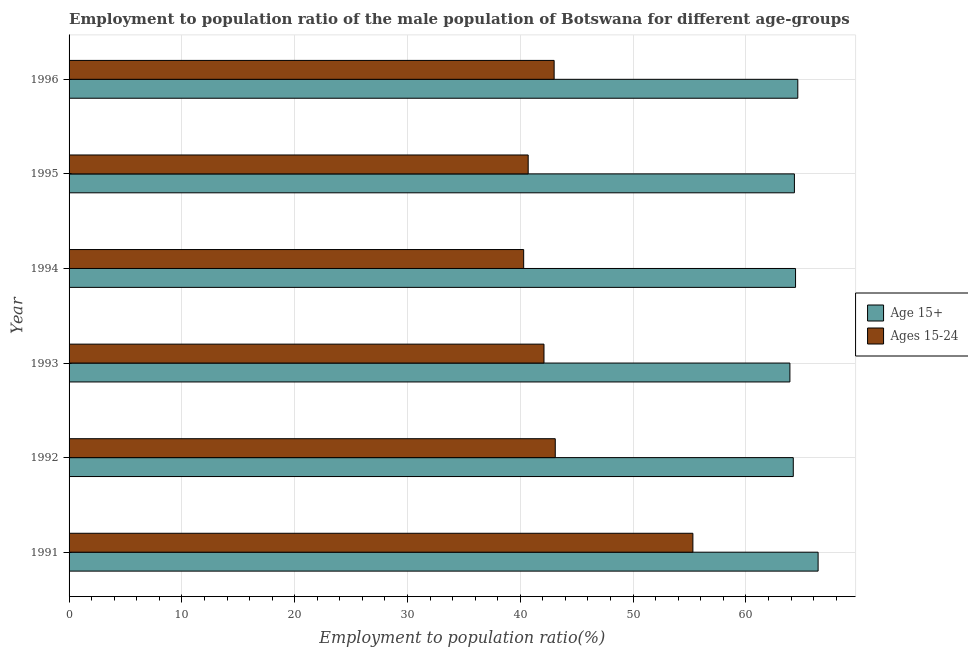How many bars are there on the 3rd tick from the bottom?
Provide a succinct answer. 2. What is the label of the 5th group of bars from the top?
Provide a short and direct response. 1992. In how many cases, is the number of bars for a given year not equal to the number of legend labels?
Offer a very short reply. 0. What is the employment to population ratio(age 15+) in 1996?
Offer a very short reply. 64.6. Across all years, what is the maximum employment to population ratio(age 15-24)?
Keep it short and to the point. 55.3. Across all years, what is the minimum employment to population ratio(age 15-24)?
Keep it short and to the point. 40.3. What is the total employment to population ratio(age 15+) in the graph?
Give a very brief answer. 387.8. What is the difference between the employment to population ratio(age 15-24) in 1991 and the employment to population ratio(age 15+) in 1993?
Ensure brevity in your answer.  -8.6. What is the average employment to population ratio(age 15-24) per year?
Keep it short and to the point. 44.08. In the year 1996, what is the difference between the employment to population ratio(age 15-24) and employment to population ratio(age 15+)?
Your response must be concise. -21.6. In how many years, is the employment to population ratio(age 15-24) greater than 44 %?
Your answer should be very brief. 1. What is the ratio of the employment to population ratio(age 15+) in 1995 to that in 1996?
Offer a very short reply. 0.99. Is the employment to population ratio(age 15+) in 1991 less than that in 1993?
Provide a short and direct response. No. Is the difference between the employment to population ratio(age 15+) in 1994 and 1996 greater than the difference between the employment to population ratio(age 15-24) in 1994 and 1996?
Keep it short and to the point. Yes. What is the difference between the highest and the second highest employment to population ratio(age 15-24)?
Your answer should be compact. 12.2. What is the difference between the highest and the lowest employment to population ratio(age 15+)?
Provide a short and direct response. 2.5. In how many years, is the employment to population ratio(age 15+) greater than the average employment to population ratio(age 15+) taken over all years?
Offer a terse response. 1. What does the 1st bar from the top in 1993 represents?
Offer a terse response. Ages 15-24. What does the 1st bar from the bottom in 1994 represents?
Ensure brevity in your answer.  Age 15+. How many bars are there?
Your answer should be very brief. 12. How many years are there in the graph?
Your answer should be very brief. 6. Does the graph contain any zero values?
Provide a short and direct response. No. How many legend labels are there?
Your response must be concise. 2. How are the legend labels stacked?
Make the answer very short. Vertical. What is the title of the graph?
Your response must be concise. Employment to population ratio of the male population of Botswana for different age-groups. Does "Forest" appear as one of the legend labels in the graph?
Keep it short and to the point. No. What is the label or title of the Y-axis?
Your answer should be very brief. Year. What is the Employment to population ratio(%) in Age 15+ in 1991?
Keep it short and to the point. 66.4. What is the Employment to population ratio(%) of Ages 15-24 in 1991?
Give a very brief answer. 55.3. What is the Employment to population ratio(%) in Age 15+ in 1992?
Keep it short and to the point. 64.2. What is the Employment to population ratio(%) in Ages 15-24 in 1992?
Your response must be concise. 43.1. What is the Employment to population ratio(%) in Age 15+ in 1993?
Make the answer very short. 63.9. What is the Employment to population ratio(%) in Ages 15-24 in 1993?
Keep it short and to the point. 42.1. What is the Employment to population ratio(%) of Age 15+ in 1994?
Your response must be concise. 64.4. What is the Employment to population ratio(%) in Ages 15-24 in 1994?
Provide a succinct answer. 40.3. What is the Employment to population ratio(%) in Age 15+ in 1995?
Keep it short and to the point. 64.3. What is the Employment to population ratio(%) of Ages 15-24 in 1995?
Keep it short and to the point. 40.7. What is the Employment to population ratio(%) in Age 15+ in 1996?
Offer a very short reply. 64.6. Across all years, what is the maximum Employment to population ratio(%) in Age 15+?
Your response must be concise. 66.4. Across all years, what is the maximum Employment to population ratio(%) of Ages 15-24?
Provide a short and direct response. 55.3. Across all years, what is the minimum Employment to population ratio(%) in Age 15+?
Keep it short and to the point. 63.9. Across all years, what is the minimum Employment to population ratio(%) in Ages 15-24?
Your answer should be very brief. 40.3. What is the total Employment to population ratio(%) in Age 15+ in the graph?
Keep it short and to the point. 387.8. What is the total Employment to population ratio(%) of Ages 15-24 in the graph?
Your answer should be compact. 264.5. What is the difference between the Employment to population ratio(%) in Age 15+ in 1991 and that in 1992?
Give a very brief answer. 2.2. What is the difference between the Employment to population ratio(%) in Ages 15-24 in 1991 and that in 1992?
Your response must be concise. 12.2. What is the difference between the Employment to population ratio(%) of Ages 15-24 in 1991 and that in 1993?
Provide a short and direct response. 13.2. What is the difference between the Employment to population ratio(%) in Ages 15-24 in 1991 and that in 1994?
Your answer should be very brief. 15. What is the difference between the Employment to population ratio(%) of Age 15+ in 1991 and that in 1996?
Provide a short and direct response. 1.8. What is the difference between the Employment to population ratio(%) in Ages 15-24 in 1991 and that in 1996?
Offer a very short reply. 12.3. What is the difference between the Employment to population ratio(%) of Age 15+ in 1992 and that in 1993?
Offer a terse response. 0.3. What is the difference between the Employment to population ratio(%) of Ages 15-24 in 1992 and that in 1993?
Offer a terse response. 1. What is the difference between the Employment to population ratio(%) in Age 15+ in 1992 and that in 1994?
Keep it short and to the point. -0.2. What is the difference between the Employment to population ratio(%) in Ages 15-24 in 1992 and that in 1994?
Provide a short and direct response. 2.8. What is the difference between the Employment to population ratio(%) of Ages 15-24 in 1992 and that in 1995?
Offer a very short reply. 2.4. What is the difference between the Employment to population ratio(%) of Ages 15-24 in 1992 and that in 1996?
Offer a very short reply. 0.1. What is the difference between the Employment to population ratio(%) in Age 15+ in 1993 and that in 1994?
Make the answer very short. -0.5. What is the difference between the Employment to population ratio(%) in Ages 15-24 in 1993 and that in 1994?
Provide a succinct answer. 1.8. What is the difference between the Employment to population ratio(%) of Ages 15-24 in 1993 and that in 1995?
Provide a short and direct response. 1.4. What is the difference between the Employment to population ratio(%) of Age 15+ in 1993 and that in 1996?
Ensure brevity in your answer.  -0.7. What is the difference between the Employment to population ratio(%) of Ages 15-24 in 1993 and that in 1996?
Your response must be concise. -0.9. What is the difference between the Employment to population ratio(%) in Ages 15-24 in 1994 and that in 1995?
Give a very brief answer. -0.4. What is the difference between the Employment to population ratio(%) in Age 15+ in 1995 and that in 1996?
Offer a very short reply. -0.3. What is the difference between the Employment to population ratio(%) of Age 15+ in 1991 and the Employment to population ratio(%) of Ages 15-24 in 1992?
Offer a terse response. 23.3. What is the difference between the Employment to population ratio(%) in Age 15+ in 1991 and the Employment to population ratio(%) in Ages 15-24 in 1993?
Provide a short and direct response. 24.3. What is the difference between the Employment to population ratio(%) of Age 15+ in 1991 and the Employment to population ratio(%) of Ages 15-24 in 1994?
Your answer should be very brief. 26.1. What is the difference between the Employment to population ratio(%) in Age 15+ in 1991 and the Employment to population ratio(%) in Ages 15-24 in 1995?
Provide a succinct answer. 25.7. What is the difference between the Employment to population ratio(%) of Age 15+ in 1991 and the Employment to population ratio(%) of Ages 15-24 in 1996?
Make the answer very short. 23.4. What is the difference between the Employment to population ratio(%) of Age 15+ in 1992 and the Employment to population ratio(%) of Ages 15-24 in 1993?
Ensure brevity in your answer.  22.1. What is the difference between the Employment to population ratio(%) of Age 15+ in 1992 and the Employment to population ratio(%) of Ages 15-24 in 1994?
Provide a short and direct response. 23.9. What is the difference between the Employment to population ratio(%) in Age 15+ in 1992 and the Employment to population ratio(%) in Ages 15-24 in 1996?
Your answer should be compact. 21.2. What is the difference between the Employment to population ratio(%) of Age 15+ in 1993 and the Employment to population ratio(%) of Ages 15-24 in 1994?
Your answer should be very brief. 23.6. What is the difference between the Employment to population ratio(%) of Age 15+ in 1993 and the Employment to population ratio(%) of Ages 15-24 in 1995?
Provide a short and direct response. 23.2. What is the difference between the Employment to population ratio(%) of Age 15+ in 1993 and the Employment to population ratio(%) of Ages 15-24 in 1996?
Ensure brevity in your answer.  20.9. What is the difference between the Employment to population ratio(%) in Age 15+ in 1994 and the Employment to population ratio(%) in Ages 15-24 in 1995?
Make the answer very short. 23.7. What is the difference between the Employment to population ratio(%) in Age 15+ in 1994 and the Employment to population ratio(%) in Ages 15-24 in 1996?
Provide a succinct answer. 21.4. What is the difference between the Employment to population ratio(%) of Age 15+ in 1995 and the Employment to population ratio(%) of Ages 15-24 in 1996?
Provide a short and direct response. 21.3. What is the average Employment to population ratio(%) in Age 15+ per year?
Keep it short and to the point. 64.63. What is the average Employment to population ratio(%) in Ages 15-24 per year?
Give a very brief answer. 44.08. In the year 1992, what is the difference between the Employment to population ratio(%) of Age 15+ and Employment to population ratio(%) of Ages 15-24?
Provide a succinct answer. 21.1. In the year 1993, what is the difference between the Employment to population ratio(%) of Age 15+ and Employment to population ratio(%) of Ages 15-24?
Give a very brief answer. 21.8. In the year 1994, what is the difference between the Employment to population ratio(%) in Age 15+ and Employment to population ratio(%) in Ages 15-24?
Provide a succinct answer. 24.1. In the year 1995, what is the difference between the Employment to population ratio(%) of Age 15+ and Employment to population ratio(%) of Ages 15-24?
Your answer should be compact. 23.6. In the year 1996, what is the difference between the Employment to population ratio(%) of Age 15+ and Employment to population ratio(%) of Ages 15-24?
Provide a succinct answer. 21.6. What is the ratio of the Employment to population ratio(%) of Age 15+ in 1991 to that in 1992?
Your answer should be compact. 1.03. What is the ratio of the Employment to population ratio(%) in Ages 15-24 in 1991 to that in 1992?
Keep it short and to the point. 1.28. What is the ratio of the Employment to population ratio(%) of Age 15+ in 1991 to that in 1993?
Provide a succinct answer. 1.04. What is the ratio of the Employment to population ratio(%) of Ages 15-24 in 1991 to that in 1993?
Give a very brief answer. 1.31. What is the ratio of the Employment to population ratio(%) of Age 15+ in 1991 to that in 1994?
Your answer should be compact. 1.03. What is the ratio of the Employment to population ratio(%) of Ages 15-24 in 1991 to that in 1994?
Keep it short and to the point. 1.37. What is the ratio of the Employment to population ratio(%) of Age 15+ in 1991 to that in 1995?
Give a very brief answer. 1.03. What is the ratio of the Employment to population ratio(%) in Ages 15-24 in 1991 to that in 1995?
Your response must be concise. 1.36. What is the ratio of the Employment to population ratio(%) in Age 15+ in 1991 to that in 1996?
Keep it short and to the point. 1.03. What is the ratio of the Employment to population ratio(%) in Ages 15-24 in 1991 to that in 1996?
Offer a terse response. 1.29. What is the ratio of the Employment to population ratio(%) of Ages 15-24 in 1992 to that in 1993?
Your answer should be very brief. 1.02. What is the ratio of the Employment to population ratio(%) in Ages 15-24 in 1992 to that in 1994?
Provide a succinct answer. 1.07. What is the ratio of the Employment to population ratio(%) in Ages 15-24 in 1992 to that in 1995?
Offer a very short reply. 1.06. What is the ratio of the Employment to population ratio(%) in Age 15+ in 1992 to that in 1996?
Your response must be concise. 0.99. What is the ratio of the Employment to population ratio(%) in Age 15+ in 1993 to that in 1994?
Your answer should be very brief. 0.99. What is the ratio of the Employment to population ratio(%) in Ages 15-24 in 1993 to that in 1994?
Keep it short and to the point. 1.04. What is the ratio of the Employment to population ratio(%) in Ages 15-24 in 1993 to that in 1995?
Your answer should be very brief. 1.03. What is the ratio of the Employment to population ratio(%) of Age 15+ in 1993 to that in 1996?
Make the answer very short. 0.99. What is the ratio of the Employment to population ratio(%) in Ages 15-24 in 1993 to that in 1996?
Make the answer very short. 0.98. What is the ratio of the Employment to population ratio(%) in Ages 15-24 in 1994 to that in 1995?
Ensure brevity in your answer.  0.99. What is the ratio of the Employment to population ratio(%) of Ages 15-24 in 1994 to that in 1996?
Ensure brevity in your answer.  0.94. What is the ratio of the Employment to population ratio(%) in Ages 15-24 in 1995 to that in 1996?
Provide a succinct answer. 0.95. What is the difference between the highest and the lowest Employment to population ratio(%) of Ages 15-24?
Give a very brief answer. 15. 